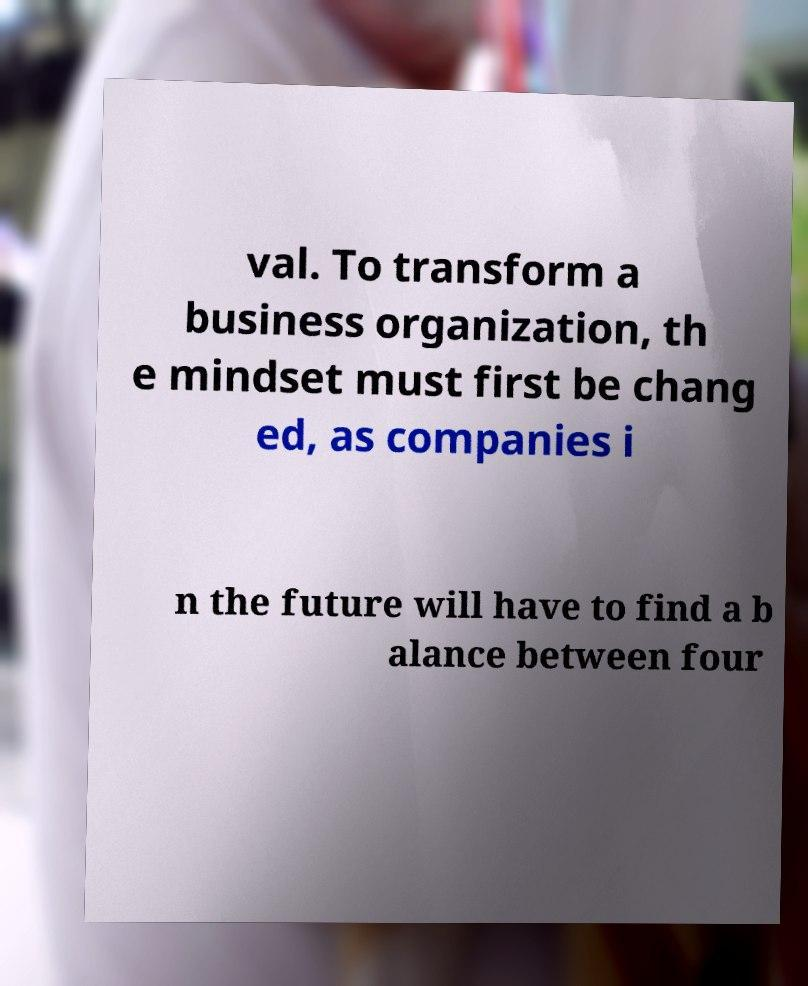Please identify and transcribe the text found in this image. val. To transform a business organization, th e mindset must first be chang ed, as companies i n the future will have to find a b alance between four 